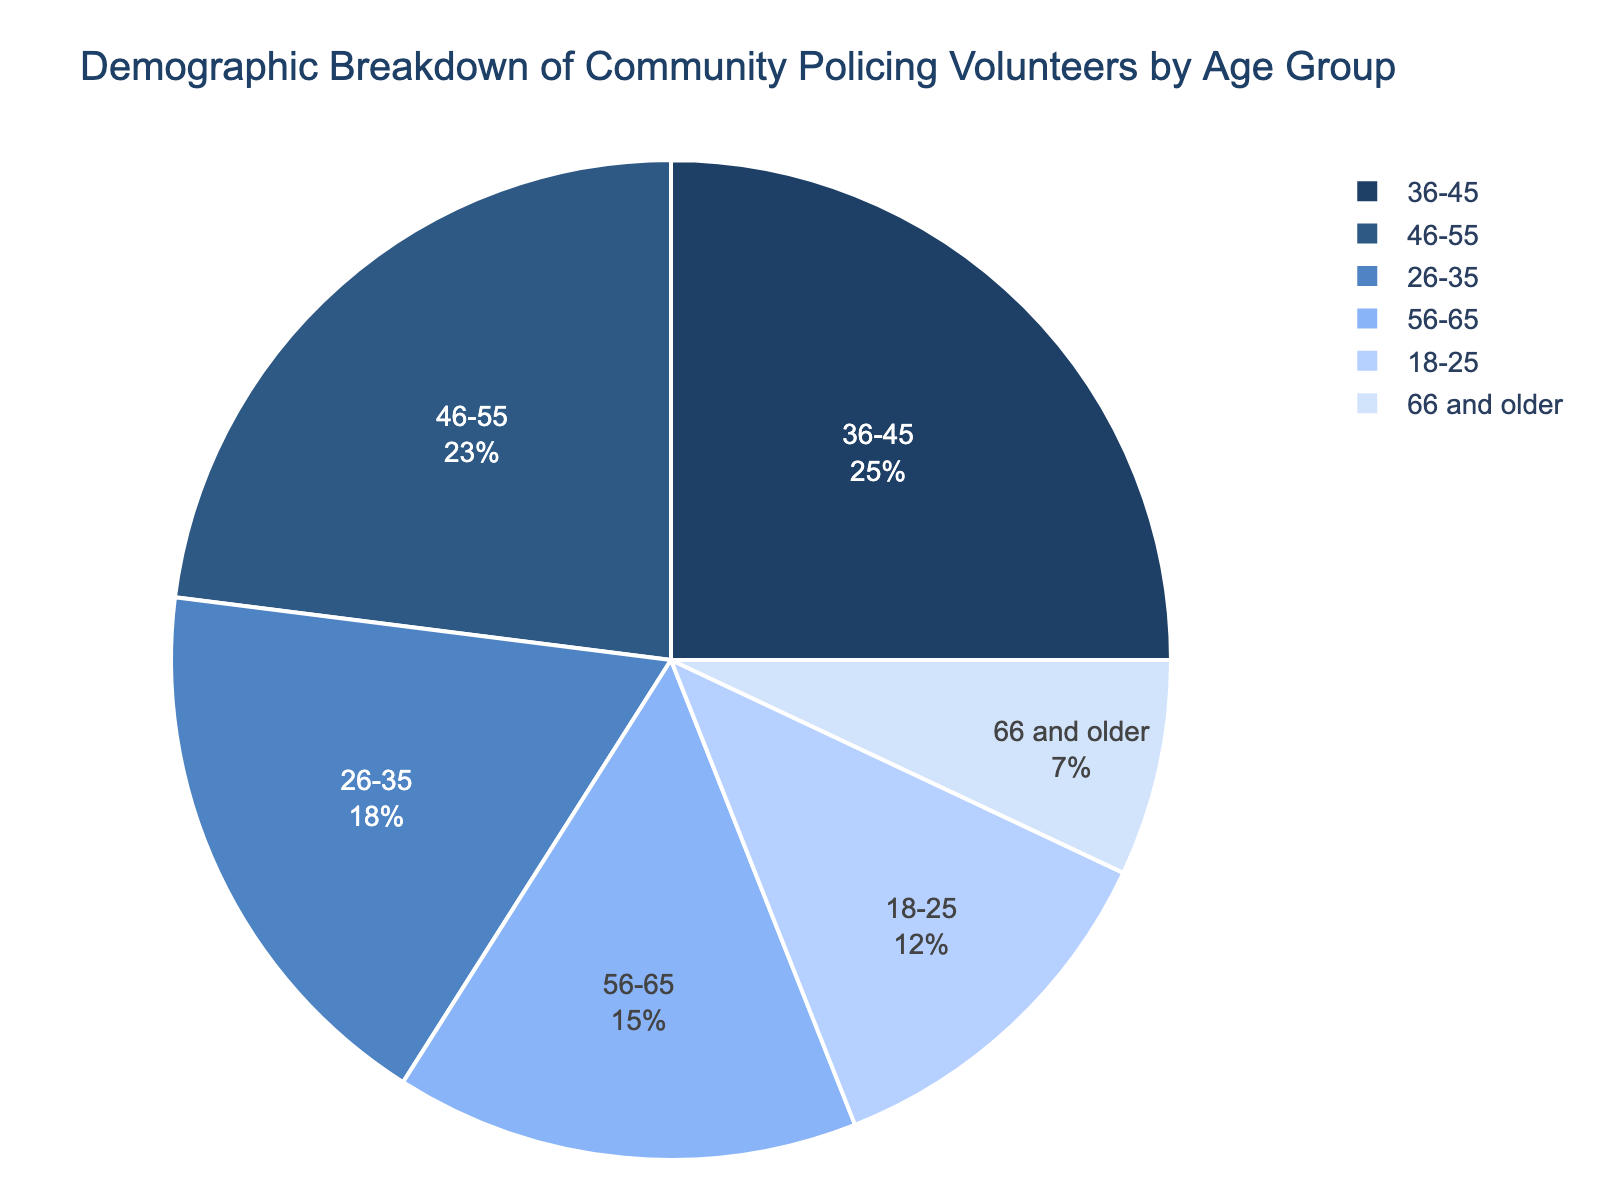What's the largest age group of community policing volunteers? Look at the slice of the pie chart with the largest percentage. The 36-45 age group has the highest percentage at 25%.
Answer: 36-45 Which age groups have percentages below 10%? Identify the slices with percentages below 10%. The 66 and older age group has 7%.
Answer: 66 and older What's the combined percentage of volunteers aged between 18-35? Add the percentages of the 18-25 and 26-35 age groups: 12% + 18% = 30%.
Answer: 30% Is the percentage of volunteers aged 46-55 greater than those aged 56-65? Compare the percentages of the 46-55 and 56-65 age groups. The 46-55 age group has 23% while the 56-65 age group has 15%.
Answer: Yes What is the percentage difference between the age groups 36-45 and 18-25? Subtract the percentage of the 18-25 age group from the 36-45 age group: 25% - 12% = 13%.
Answer: 13% Which age group has a smaller percentage, 26-35 or 56-65? Compare the percentages of the 26-35 and 56-65 age groups. The 56-65 age group has a smaller percentage at 15%, while 26-35 has 18%.
Answer: 56-65 What's the total percentage of volunteers aged above 55? Add the percentages of the 56-65 and 66 and older age groups: 15% + 7% = 22%.
Answer: 22% Which two adjacent age groups have the closest percentages? Compare adjacent age groups and find the smallest difference. The 46-55 (23%) and 56-65 (15%) groups have a difference of 23% - 15% = 8%.
Answer: 46-55 and 56-65 What color represents the 26-35 age group in the pie chart? Identify the color used in the pie chart for the 26-35 age group. It is the second slice which is blue.
Answer: Blue If a new age group 35-45 is added and it contains 10% of volunteers, what will be the new percentage for the 36-45 age group? Subtract 10% from the 36-45 age group's original percentage: 25% - 10% = 15%.
Answer: 15% 